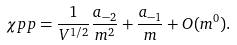<formula> <loc_0><loc_0><loc_500><loc_500>\chi p p = \frac { 1 } { V ^ { 1 / 2 } } \frac { a _ { - 2 } } { m ^ { 2 } } + \frac { a _ { - 1 } } { m } + O ( m ^ { 0 } ) .</formula> 